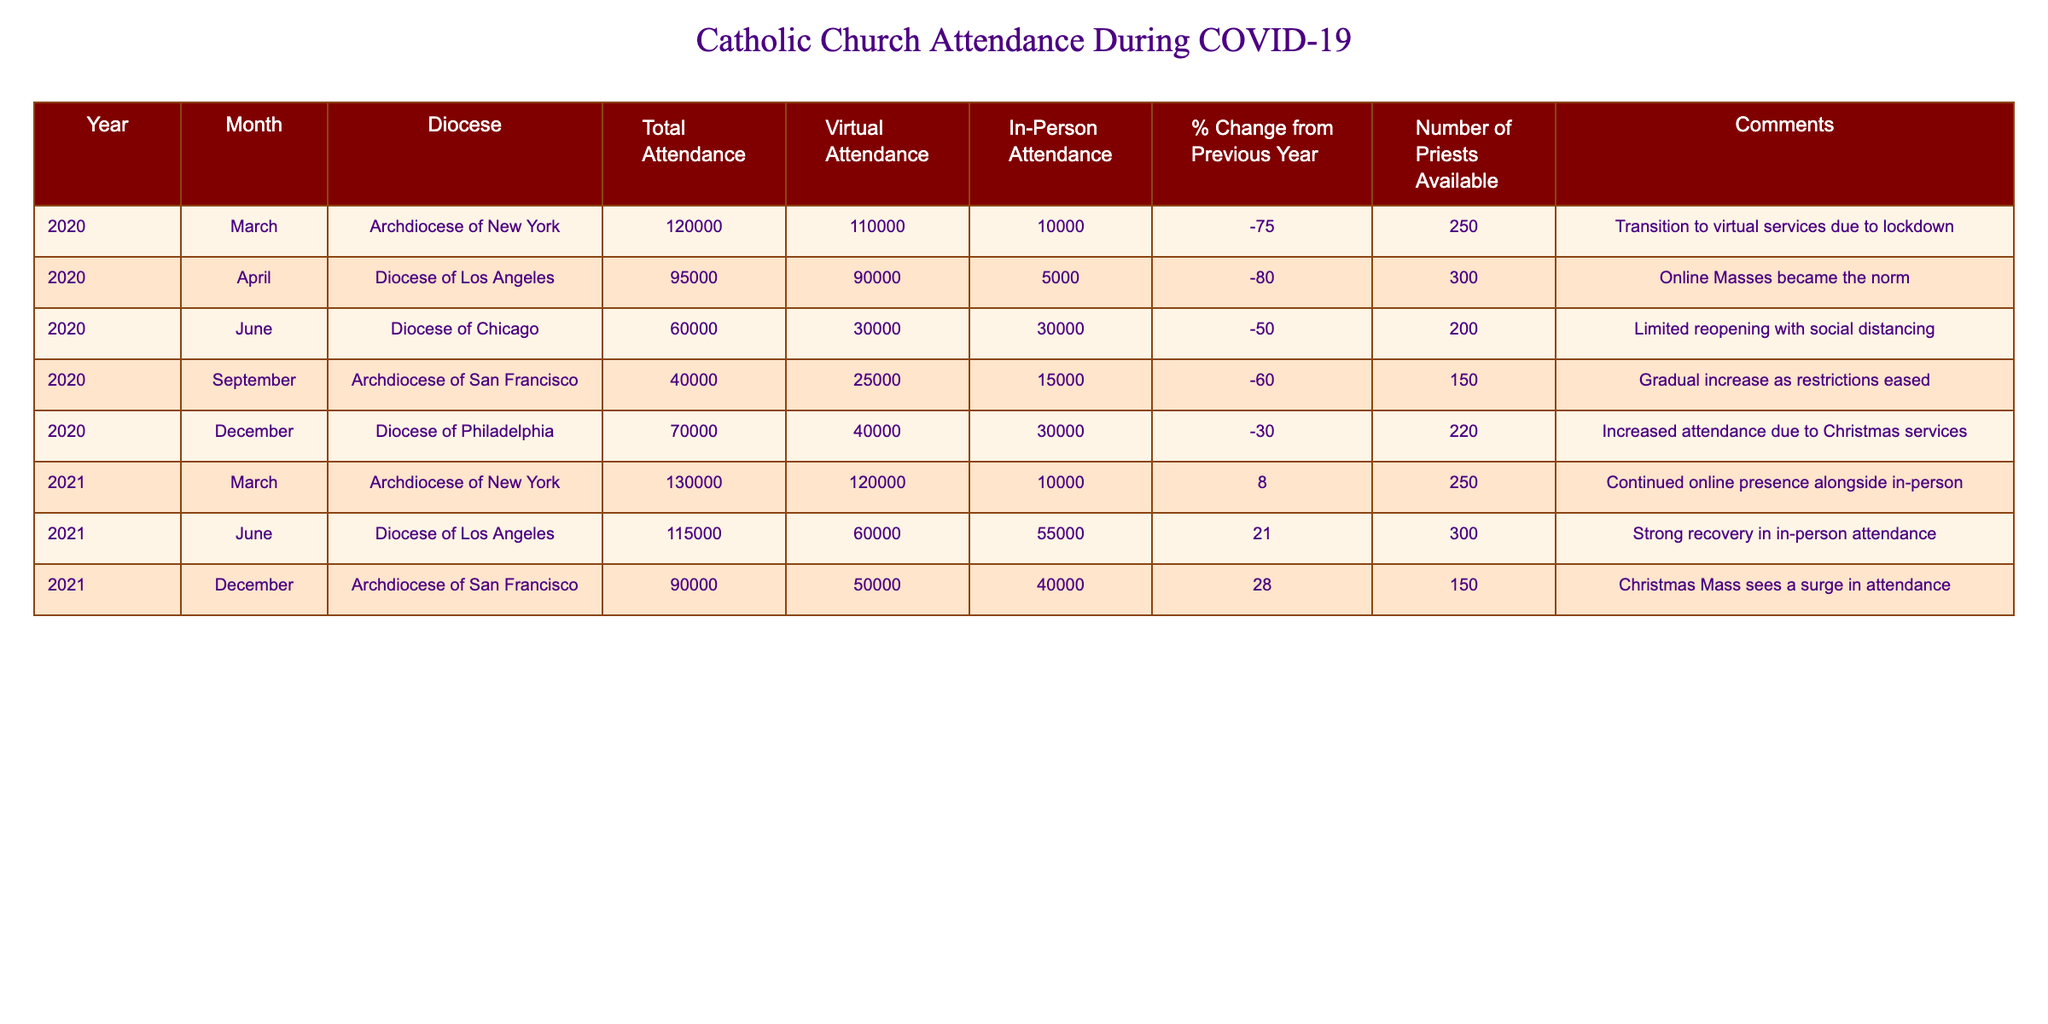What was the total attendance in December 2020 for the Diocese of Philadelphia? According to the table, the Total Attendance for the Diocese of Philadelphia in December 2020 is given as 70,000.
Answer: 70,000 What was the percentage change in total attendance from March 2020 to March 2021 in the Archdiocese of New York? The Total Attendance in March 2020 is 120,000 and in March 2021 it is 130,000. The percentage change is calculated as ((130,000 - 120,000) / 120,000) * 100, which equals approximately 8.33%.
Answer: 8.33% Did the Diocese of Los Angeles experience a decline in in-person attendance from April 2020 to June 2021? The In-Person Attendance in April 2020 was 5,000 and in June 2021 it was 55,000. Since 55,000 is greater than 5,000, it indicates an increase, not a decline.
Answer: No What was the total number of priests available in June 2020 and June 2021 combined? The Number of Priests Available in June 2020 was 200 and in June 2021 it was 300. Adding these together gives 200 + 300 = 500.
Answer: 500 How much did virtual attendance increase from March 2020 to December 2021 in the Archdiocese of San Francisco? In March 2020, the Virtual Attendance in the Archdiocese of San Francisco was not recorded, but the latest data point is in December 2021 with 50,000. Since the earlier data point is missing, we cannot determine a change.
Answer: Cannot determine What was the average in-person attendance across all listed dioceses for 2020? The In-Person Attendance for the dioceses in 2020 are 10,000 (New York), 5,000 (Los Angeles), 30,000 (Chicago), 15,000 (San Francisco), and 30,000 (Philadelphia), summing these gives 90,000. There are 5 entries, so the average is 90,000 / 5 = 18,000.
Answer: 18,000 Was there any month in 2021 with in-person attendance lower than the total attendance from the same month in 2020? In March 2021, the In-Person Attendance is 10,000 and Total Attendance in March 2020 was 120,000. Since 10,000 is lower than 120,000, this condition is met.
Answer: Yes What is the difference in total attendance between December 2020 and December 2021 for the Archdiocese of San Francisco? The available Total Attendance for December 2021 in the Archdiocese of San Francisco is missing in the provided data. Therefore, the difference cannot be calculated.
Answer: Cannot determine 